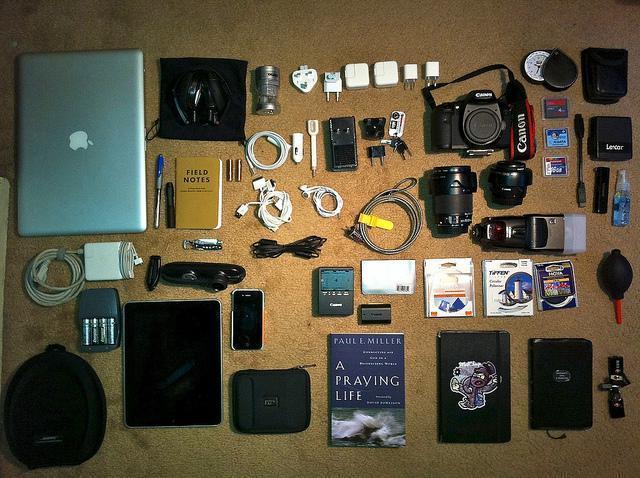The book was based on a series of what by the author?
Pick the correct solution from the four options below to address the question.
Options: Songs, seminars, dreams, sermons. Seminars. 